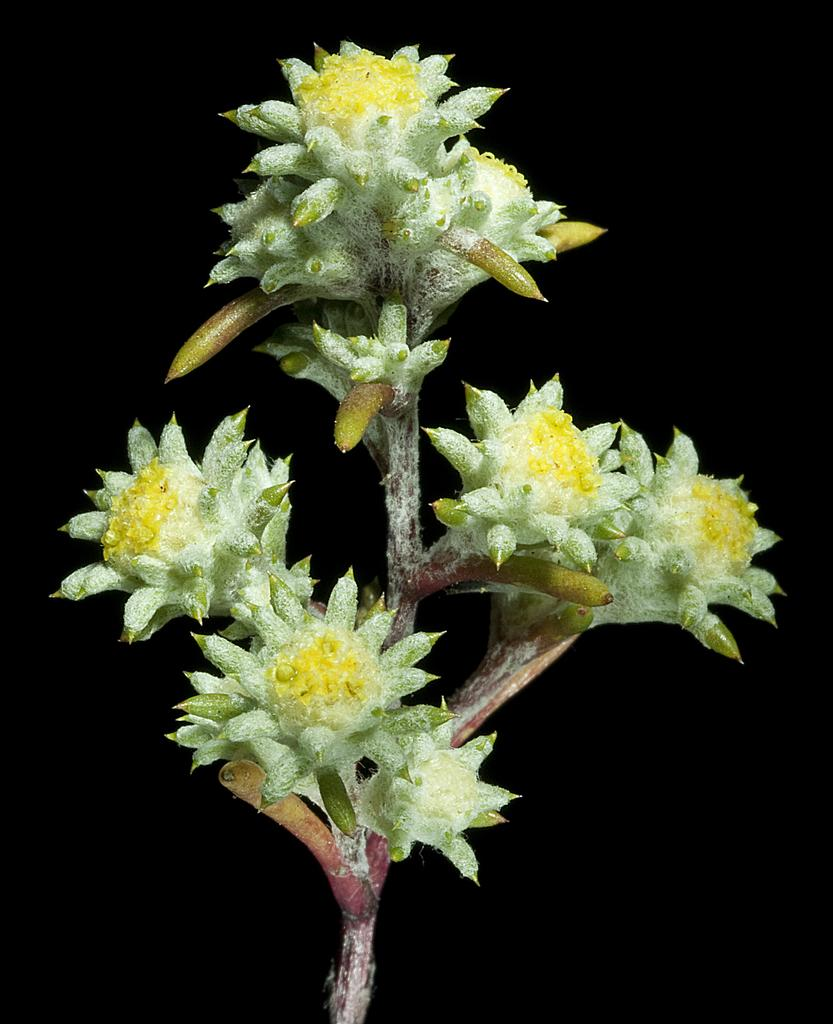What is present in the image? There is a plant in the image. Can you describe the plant in more detail? The plant has different kinds of flowers. What can be observed about the background of the image? The background of the image appears to be dark. What advertisement can be seen near the plant in the image? There is no advertisement present in the image; it only features a plant with different kinds of flowers and a dark background. 